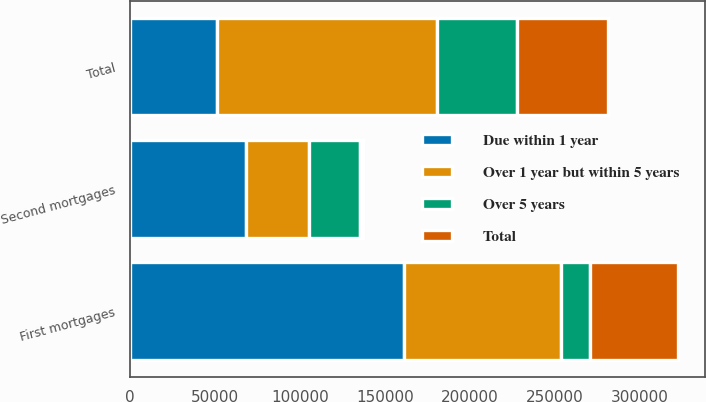Convert chart. <chart><loc_0><loc_0><loc_500><loc_500><stacked_bar_chart><ecel><fcel>First mortgages<fcel>Second mortgages<fcel>Total<nl><fcel>Over 5 years<fcel>17423<fcel>30073<fcel>47496<nl><fcel>Total<fcel>51495<fcel>1752<fcel>53247<nl><fcel>Over 1 year but within 5 years<fcel>92167<fcel>36654<fcel>128821<nl><fcel>Due within 1 year<fcel>161085<fcel>68479<fcel>51495<nl></chart> 